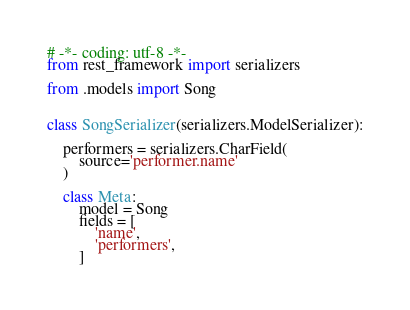Convert code to text. <code><loc_0><loc_0><loc_500><loc_500><_Python_># -*- coding: utf-8 -*-
from rest_framework import serializers

from .models import Song


class SongSerializer(serializers.ModelSerializer):

    performers = serializers.CharField(
        source='performer.name'
    )

    class Meta:
        model = Song
        fields = [
            'name',
            'performers',
        ]</code> 